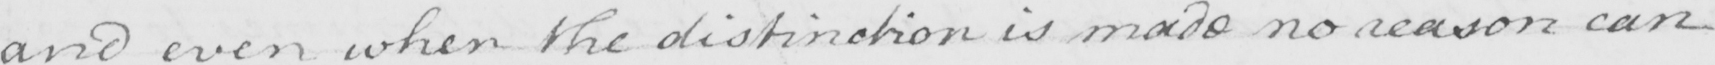What is written in this line of handwriting? and even when the distinction is made no reason can 